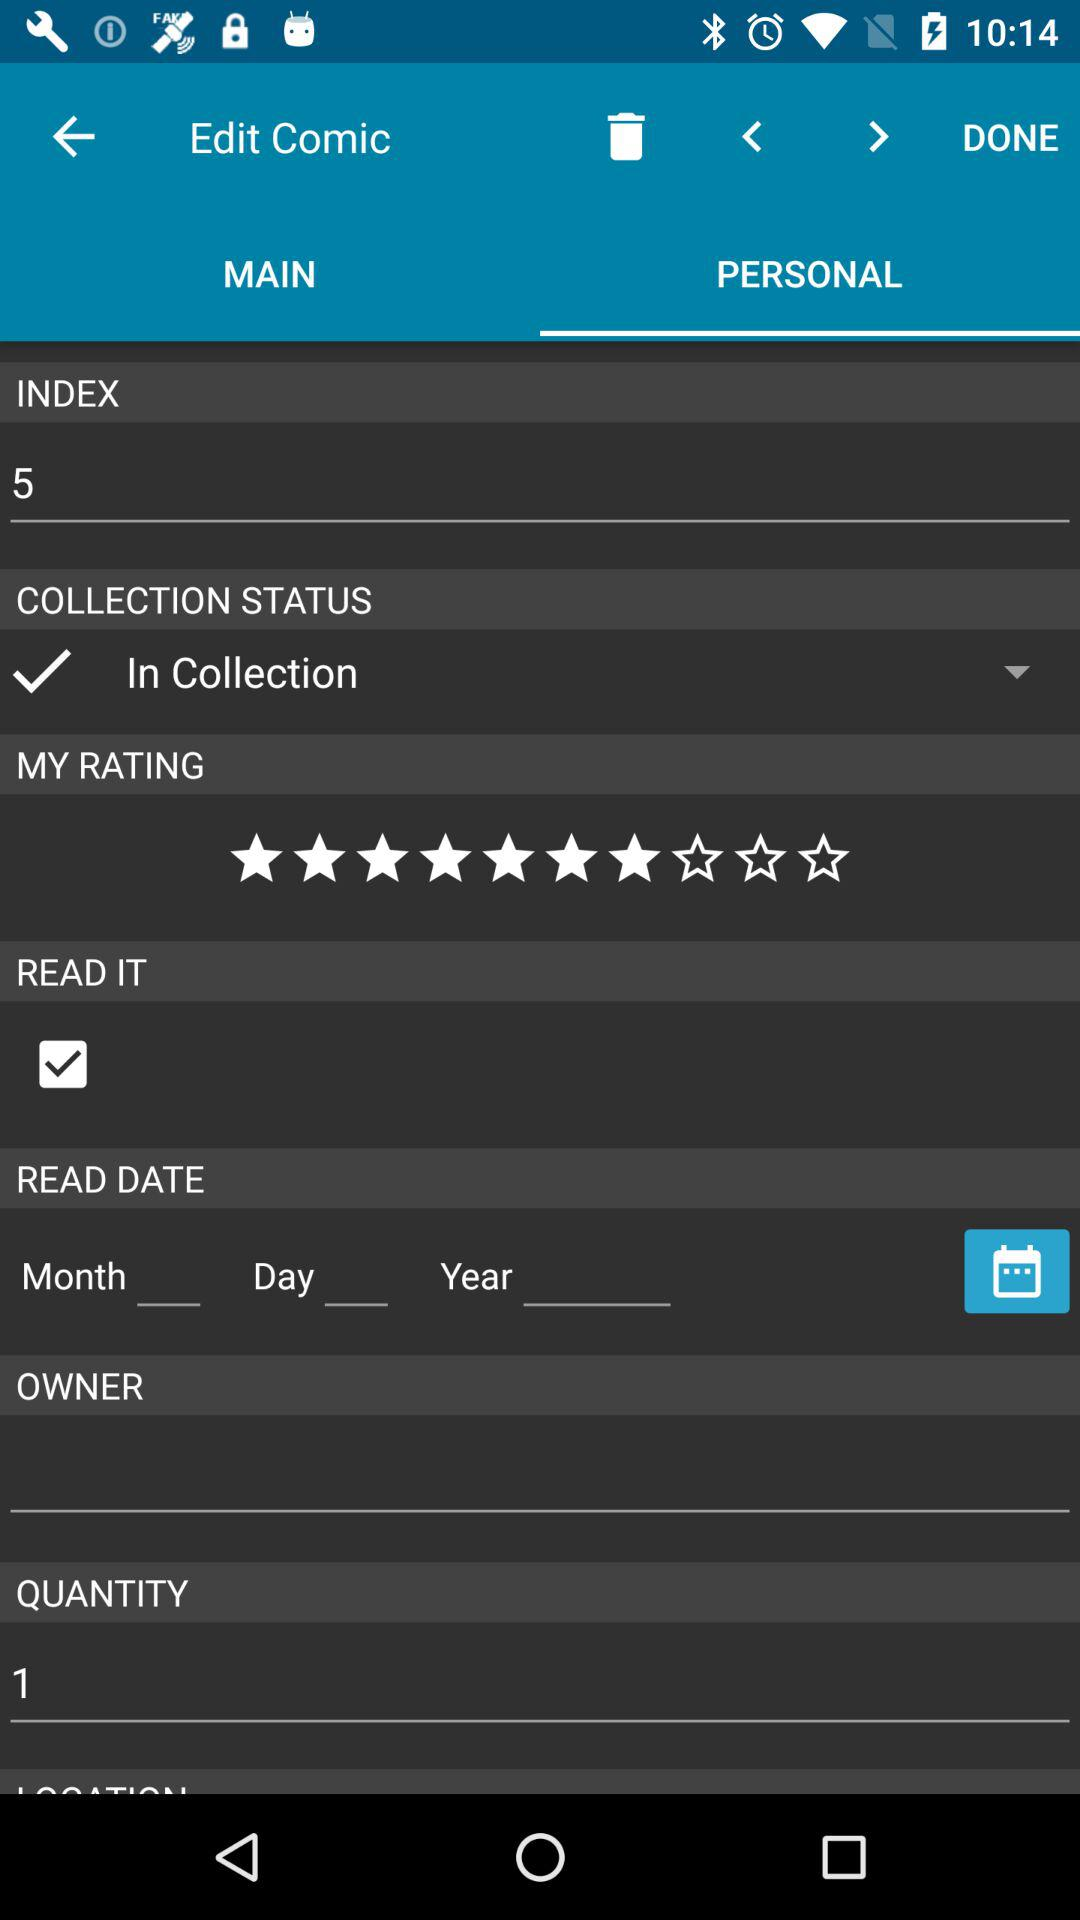What is the selected option in "COLLECTION STATUS"? The selected option in "COLLECTION STATUS" is "In Collection". 